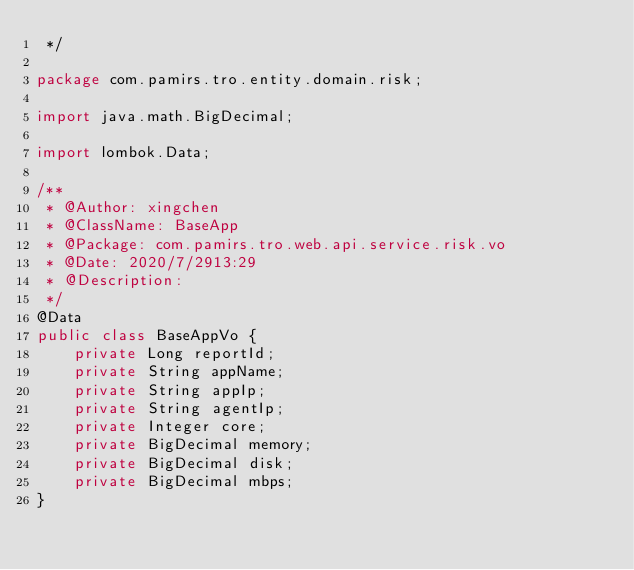Convert code to text. <code><loc_0><loc_0><loc_500><loc_500><_Java_> */

package com.pamirs.tro.entity.domain.risk;

import java.math.BigDecimal;

import lombok.Data;

/**
 * @Author: xingchen
 * @ClassName: BaseApp
 * @Package: com.pamirs.tro.web.api.service.risk.vo
 * @Date: 2020/7/2913:29
 * @Description:
 */
@Data
public class BaseAppVo {
    private Long reportId;
    private String appName;
    private String appIp;
    private String agentIp;
    private Integer core;
    private BigDecimal memory;
    private BigDecimal disk;
    private BigDecimal mbps;
}
</code> 